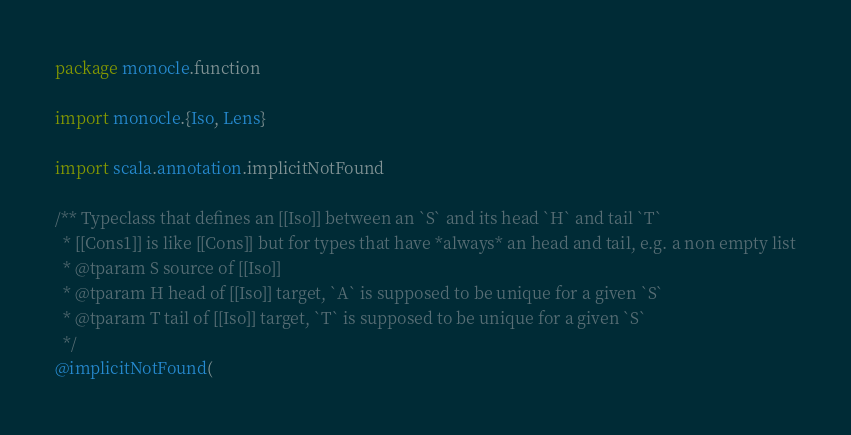Convert code to text. <code><loc_0><loc_0><loc_500><loc_500><_Scala_>package monocle.function

import monocle.{Iso, Lens}

import scala.annotation.implicitNotFound

/** Typeclass that defines an [[Iso]] between an `S` and its head `H` and tail `T`
  * [[Cons1]] is like [[Cons]] but for types that have *always* an head and tail, e.g. a non empty list
  * @tparam S source of [[Iso]]
  * @tparam H head of [[Iso]] target, `A` is supposed to be unique for a given `S`
  * @tparam T tail of [[Iso]] target, `T` is supposed to be unique for a given `S`
  */
@implicitNotFound(</code> 